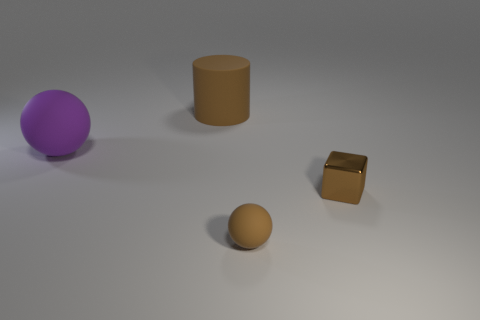Is there anything else that has the same material as the cube?
Provide a short and direct response. No. There is a brown rubber object that is in front of the big brown object; what shape is it?
Your answer should be very brief. Sphere. Is the purple ball made of the same material as the sphere that is on the right side of the purple object?
Your response must be concise. Yes. Is the shape of the purple rubber object the same as the small brown metallic thing?
Ensure brevity in your answer.  No. What is the material of the large purple object that is the same shape as the tiny brown matte thing?
Your response must be concise. Rubber. What color is the object that is both in front of the purple matte thing and behind the tiny brown ball?
Keep it short and to the point. Brown. What color is the big cylinder?
Your answer should be very brief. Brown. What material is the small cube that is the same color as the rubber cylinder?
Ensure brevity in your answer.  Metal. Are there any other small things that have the same shape as the purple thing?
Your response must be concise. Yes. What size is the ball in front of the small block?
Your answer should be compact. Small. 